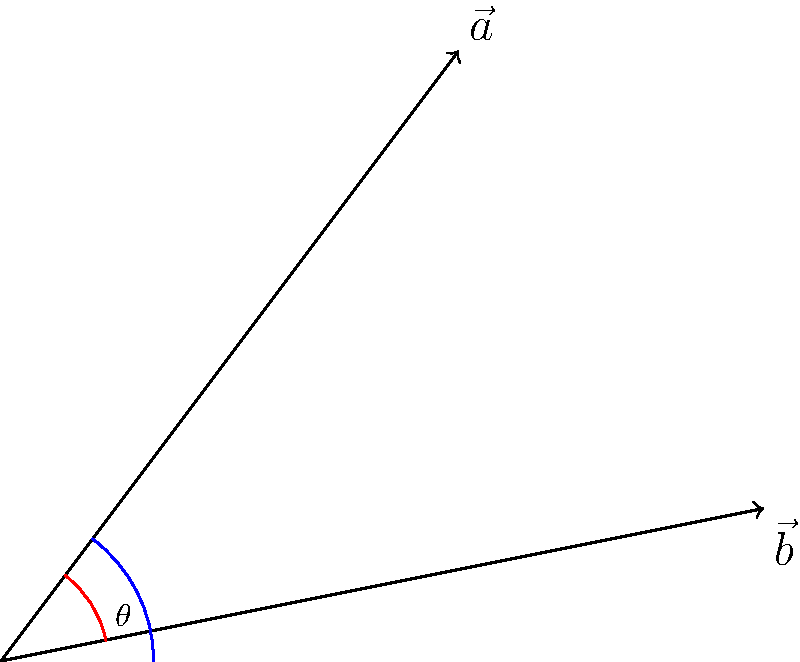During a playful chase, a dolphin and a seal swim along different paths. The dolphin's path is represented by vector $\vec{a} = 3\hat{i} + 4\hat{j}$, while the seal's path is represented by vector $\vec{b} = 5\hat{i} + \hat{j}$. What is the angle $\theta$ between these two vectors? To find the angle between two vectors, we can use the dot product formula:

$$\cos \theta = \frac{\vec{a} \cdot \vec{b}}{|\vec{a}||\vec{b}|}$$

Step 1: Calculate the dot product $\vec{a} \cdot \vec{b}$
$$\vec{a} \cdot \vec{b} = (3)(5) + (4)(1) = 15 + 4 = 19$$

Step 2: Calculate the magnitudes of $\vec{a}$ and $\vec{b}$
$$|\vec{a}| = \sqrt{3^2 + 4^2} = \sqrt{9 + 16} = \sqrt{25} = 5$$
$$|\vec{b}| = \sqrt{5^2 + 1^2} = \sqrt{25 + 1} = \sqrt{26}$$

Step 3: Substitute into the formula
$$\cos \theta = \frac{19}{5\sqrt{26}}$$

Step 4: Take the inverse cosine (arccos) of both sides
$$\theta = \arccos\left(\frac{19}{5\sqrt{26}}\right)$$

Step 5: Calculate the result (in radians)
$$\theta \approx 0.5095 \text{ radians}$$

Step 6: Convert to degrees
$$\theta \approx 0.5095 \times \frac{180}{\pi} \approx 29.20°$$
Answer: $29.20°$ 